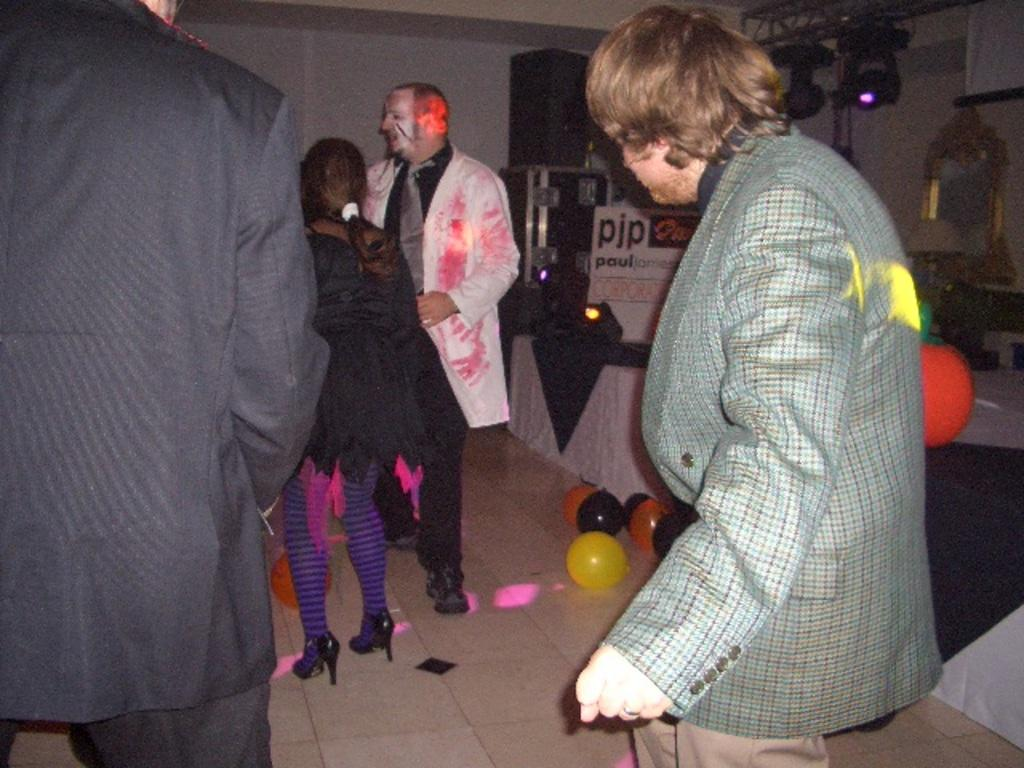What can be seen in the image involving people? There are persons standing in the image. What decorative items are present in the image? There are balloons in the image. What structure is visible in the image? There is a stage in the image. What can be seen in the background of the image? There are lights and other objects in the background of the image. What type of flag is being used to cook on the stage in the image? There is no flag or oven present in the image, so it is not possible to answer that question. 